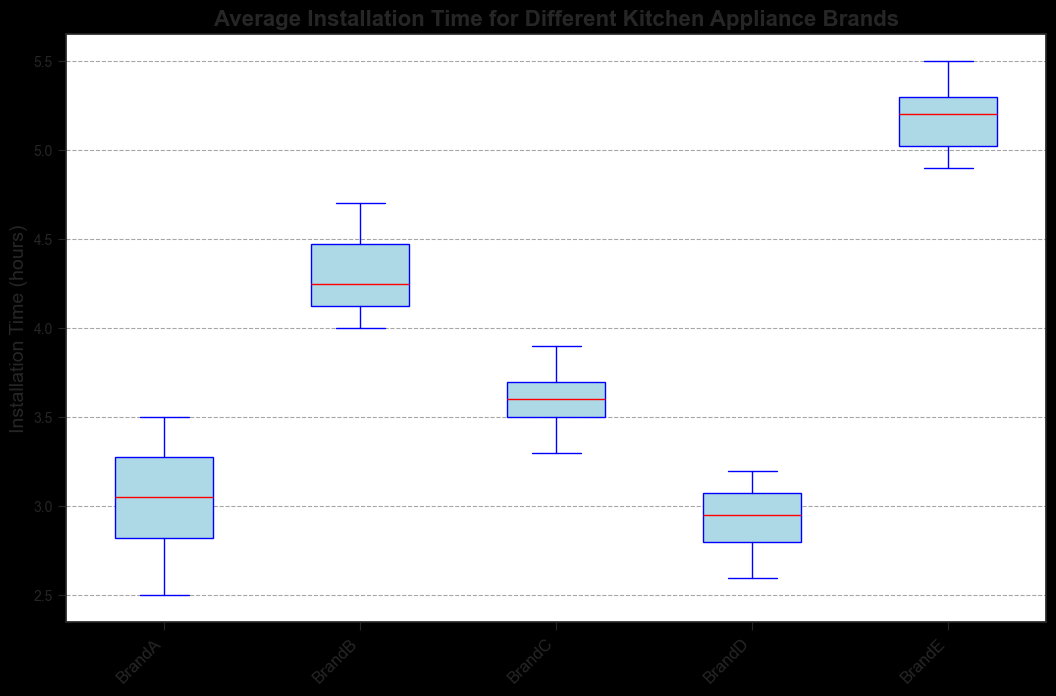What's the median installation time for BrandC? To find the median installation time, look at the red line within the BrandC box plot. The median is approximately at the value marked by this line.
Answer: 3.6 hours Which brand has the highest variability in installation times? The brand with the highest variability has the largest difference between the top and bottom of the box (interquartile range) or the whiskers. In this case, BrandE has the widest box and whiskers.
Answer: BrandE Which brand takes the longest time to install on average? The median line for each brand can be compared to determine the longest time to install. The highest median among the brands can be identified.
Answer: BrandE What is the shortest installation time recorded for BrandD? The shortest installation time is the bottom of the whisker on the BrandD box plot.
Answer: 2.6 hours Does BrandA or BrandD have tighter installation time consistency? Consistency can be determined by the width of the box plots. The box plot for BrandA is slightly wider than that for BrandD, indicating more variation.
Answer: BrandD How do the installation times for BrandB compare to those for BrandE? Compare the box plots of BrandB and BrandE. BrandE's median and whiskers are higher than BrandB’s, indicating longer installation times.
Answer: BrandB has shorter installation times By how much is the median installation time for BrandB greater than that of BrandA? Locate the red median line for both BrandB and BrandA. Subtract the median of BrandA from that of BrandB.
Answer: Approximately 1.1 hours Which brand has the second highest median installation time? Identify the median installation times marked by the red lines. BrandB has the highest at 4.3, followed by BrandC at 3.6.
Answer: BrandC Is the range of installation times for BrandC greater or lesser than that for BrandA? The range is the difference between the maximum and minimum values shown by the whiskers. BrandC’s range is shorter compared to BrandA’s.
Answer: Lesser If a client wants the quickest installation, which brand should you recommend? The brand with the lowest median installation time will be the quickest on average. Look at the red line in each box plot.
Answer: BrandA 